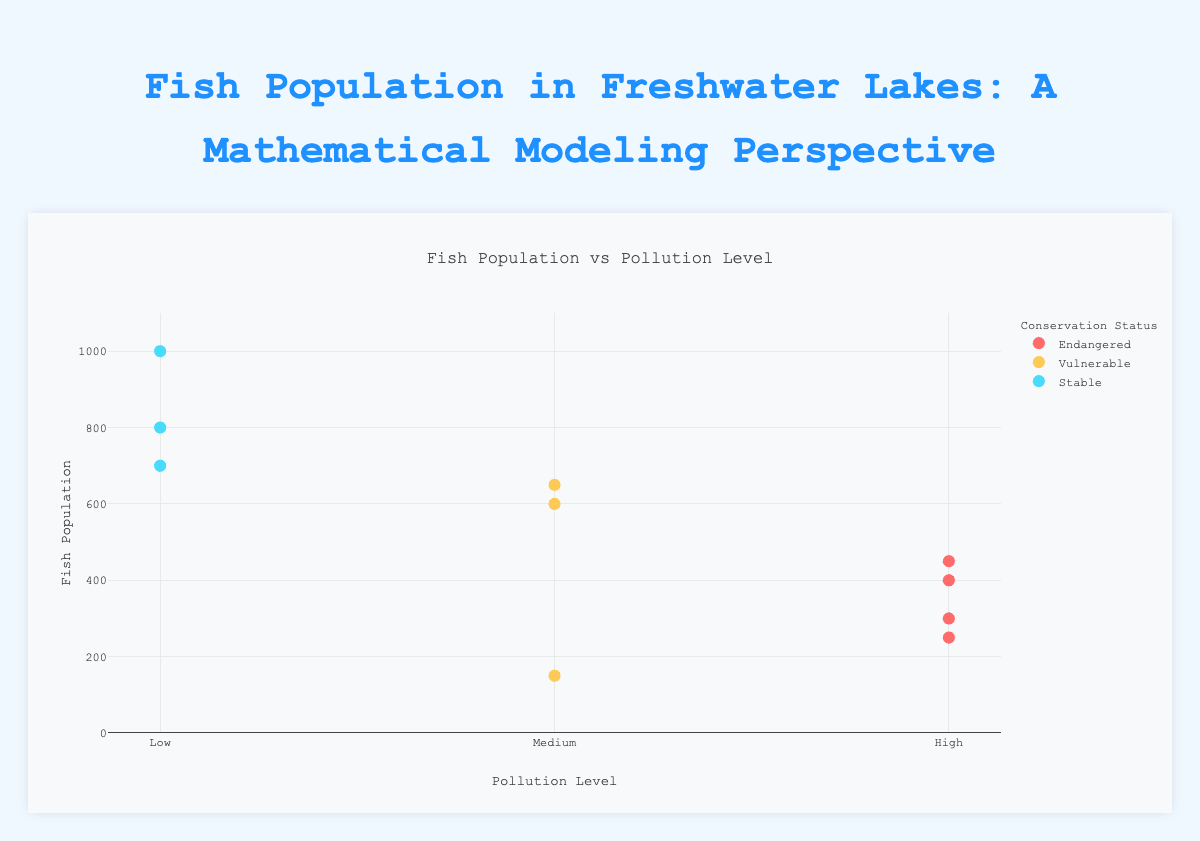what is the color used to represent "Endangered" conservation status? The figure legend shows different colors for various conservation statuses. The "Endangered" status is represented by a red color.
Answer: red which lake has the highest fish population in the "Low" pollution level category? The data points for the "Low" pollution level are labeled and indicate fish populations. Among them, Lake Superior has the highest fish population with 1000.
Answer: Lake Superior how many lakes fall into the "Medium" pollution level category and their conservation status is "Vulnerable"? The figure shows points with "Medium" pollution level and "Vulnerable" status. Lakes Ontario, Tanganyika, and Baikal meet these criteria, giving a total of three lakes.
Answer: 3 compare fish populations between "Medium" and "High" pollution levels for lakes with "Endangered" conservation status Only lakes in the "High" pollution level category have "Endangered" status: Lake Erie, Victoria, Michigan, and Ladoga. Adding their fish populations yields 1,400. There are no lakes with "Endangered" conservation status in the "Medium" pollution category.
Answer: 1,400 to 0 which lake has the lowest fish population, and what are its pollution level and conservation status? From the plot, the point with the lowest fish population corresponds to Lake Ontario with 150 fish in the "Medium" pollution level and "Vulnerable" conservation status.
Answer: Lake Ontario, Medium, Vulnerable what is the average fish population for lakes in the "High" pollution level category? The lakes in the "High" pollution level category are Erie, Victoria, Michigan, and Ladoga with fish populations of 250, 300, 400, and 450, respectively. The average is calculated as (250 + 300 + 400 + 450) / 4 = 1400 / 4 = 350.
Answer: 350 which group (by conservation status) has the greatest variation in fish population numbers? Comparing the range of fish populations (difference between highest and lowest values) within each status group: "Endangered" ranges from 250 to 450, "Vulnerable" ranges from 150 to 650, and “Stable” ranges from 700 to 1000. "Endangered" has the greatest variation.
Answer: Endangered 